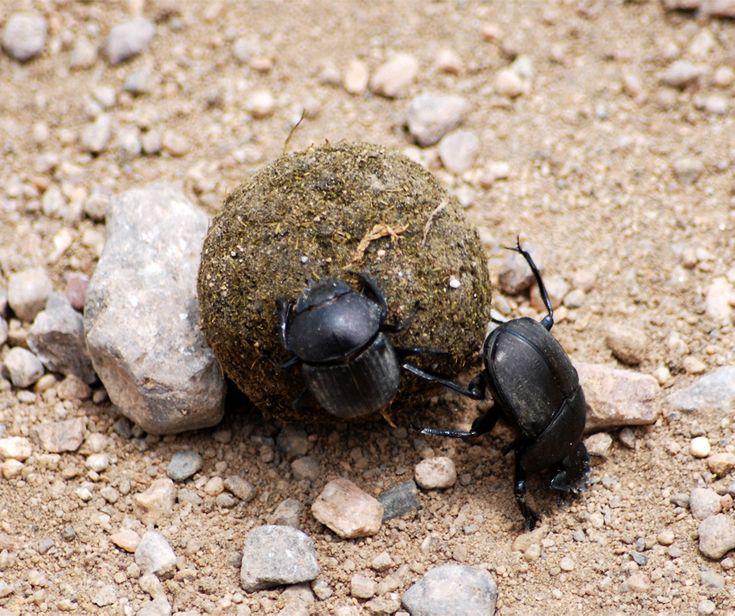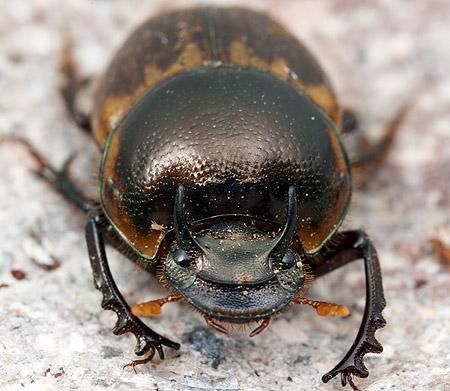The first image is the image on the left, the second image is the image on the right. Assess this claim about the two images: "There are two beetles in one of the images.". Correct or not? Answer yes or no. Yes. 